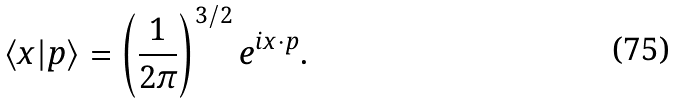Convert formula to latex. <formula><loc_0><loc_0><loc_500><loc_500>\langle x | p \rangle = \left ( \frac { 1 } { 2 \pi } \right ) ^ { 3 / 2 } e ^ { i x \cdot p } .</formula> 